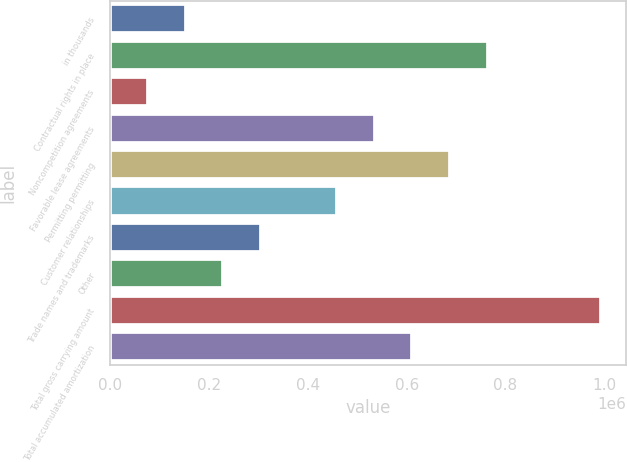<chart> <loc_0><loc_0><loc_500><loc_500><bar_chart><fcel>in thousands<fcel>Contractual rights in place<fcel>Noncompetition agreements<fcel>Favorable lease agreements<fcel>Permitting permitting<fcel>Customer relationships<fcel>Trade names and trademarks<fcel>Other<fcel>Total gross carrying amount<fcel>Total accumulated amortization<nl><fcel>152880<fcel>764383<fcel>76442.2<fcel>535069<fcel>687945<fcel>458632<fcel>305756<fcel>229318<fcel>993697<fcel>611507<nl></chart> 